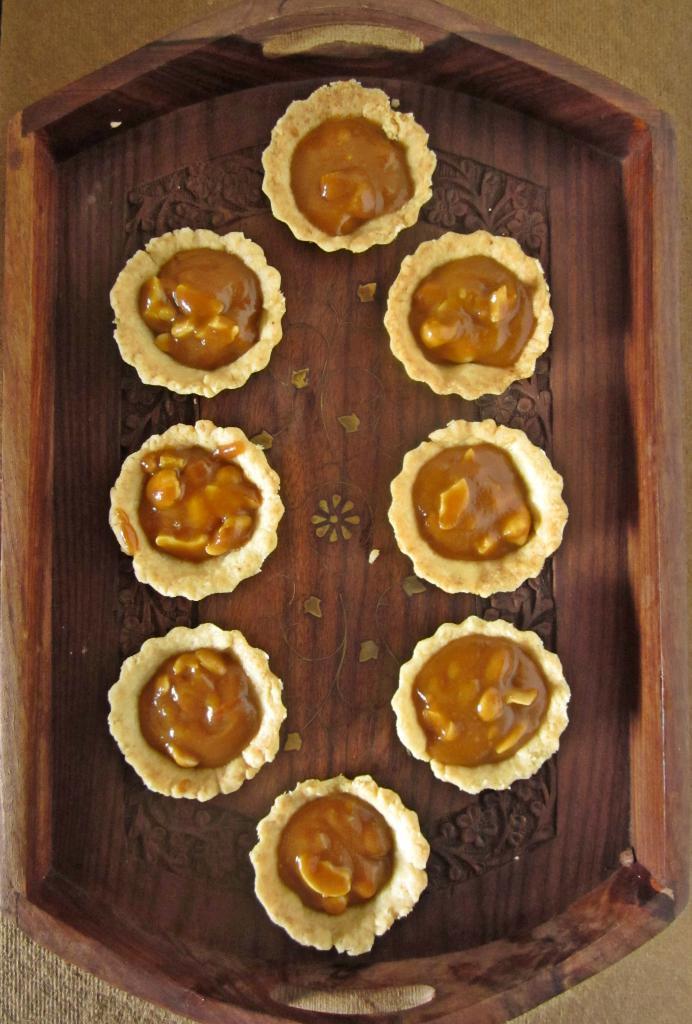In one or two sentences, can you explain what this image depicts? In this image we can see some food items are kept on the wooden tray which is placed on the surface. 